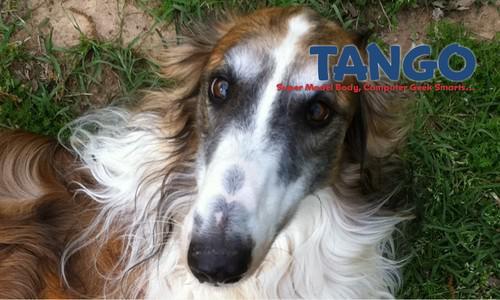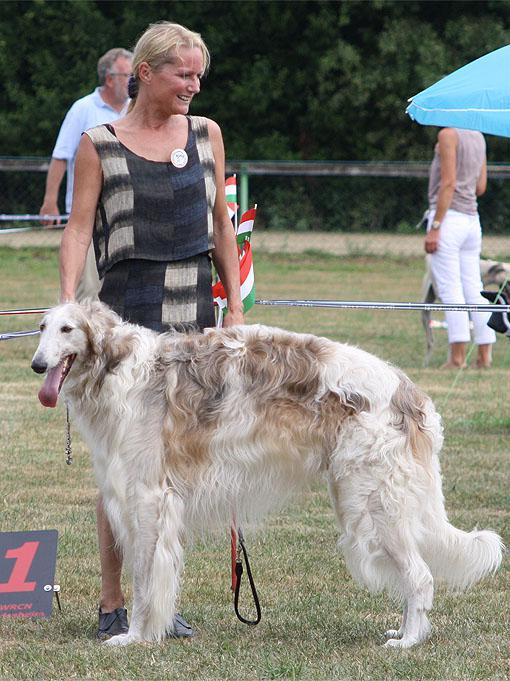The first image is the image on the left, the second image is the image on the right. Analyze the images presented: Is the assertion "At least one dog has a dark face, and the dogs in the left and right images have the same face position, with eyes gazing the same direction." valid? Answer yes or no. No. The first image is the image on the left, the second image is the image on the right. Examine the images to the left and right. Is the description "In both images only the head of the dog can be seen and not the rest of the dogs body." accurate? Answer yes or no. No. 